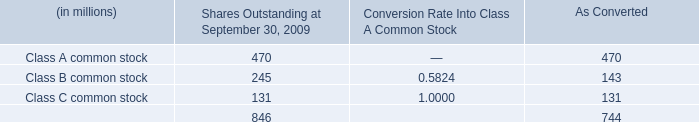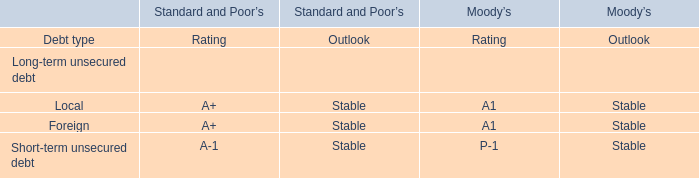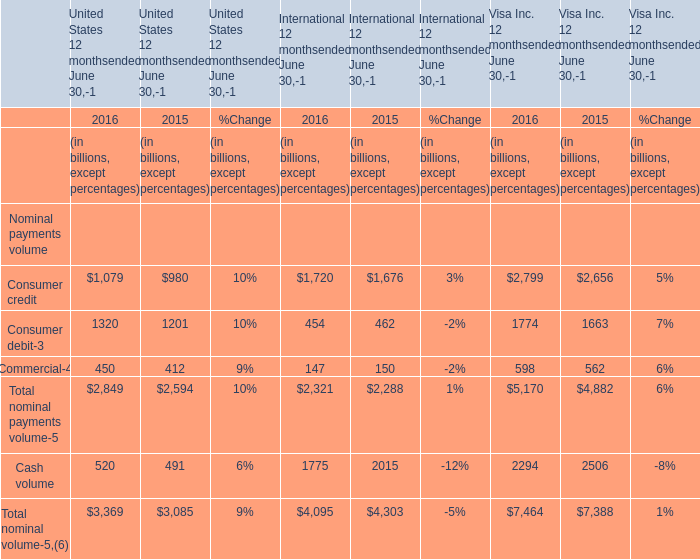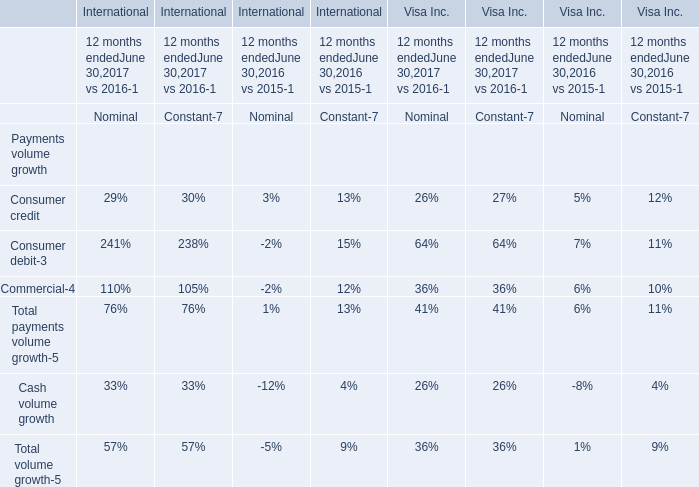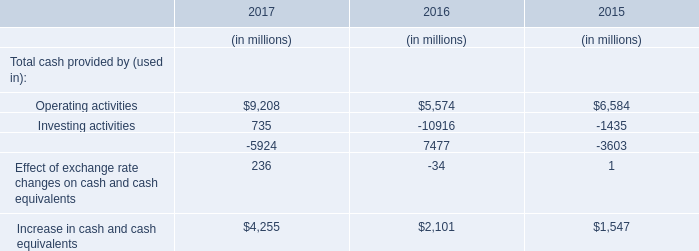What was the average value of the Total nominal payments volume in the years where Consumer credit is positive? (in billion) 
Computations: ((((((2849 + 2594) + 2321) + 2288) + 5170) + 4882) / 2)
Answer: 10052.0. 